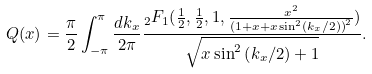Convert formula to latex. <formula><loc_0><loc_0><loc_500><loc_500>Q ( x ) = \frac { \pi } { 2 } \int _ { - \pi } ^ { \pi } \frac { d k _ { x } } { 2 \pi } \frac { _ { 2 } F _ { 1 } ( \frac { 1 } { 2 } , \frac { 1 } { 2 } , 1 , \frac { x ^ { 2 } } { \left ( 1 + x + x \sin ^ { 2 } ( k _ { x } / 2 ) \right ) ^ { 2 } } ) } { \sqrt { x \sin ^ { 2 } \left ( k _ { x } / 2 \right ) + 1 } } .</formula> 